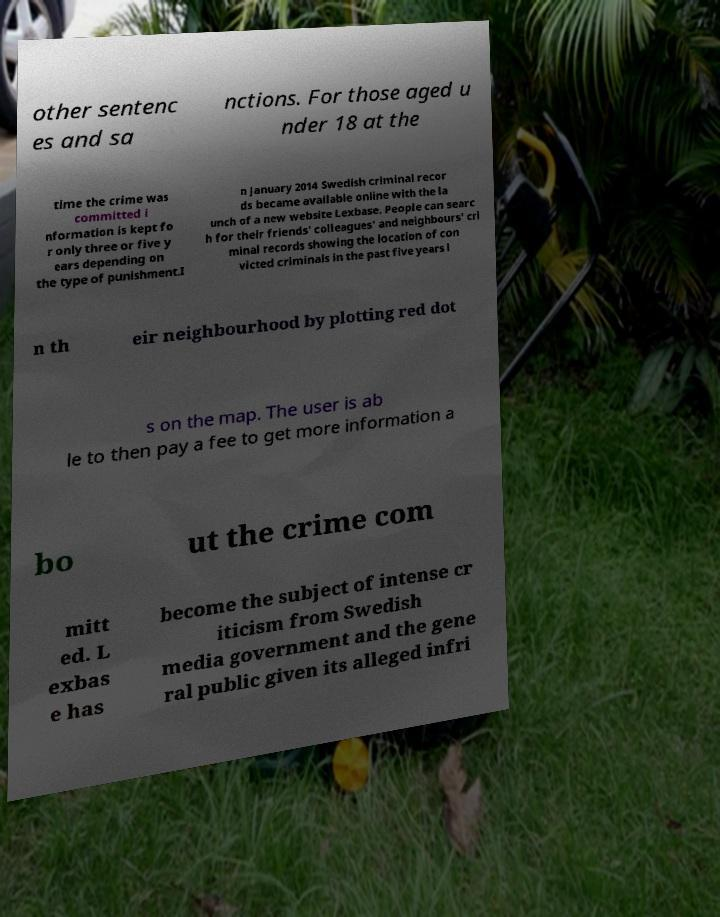For documentation purposes, I need the text within this image transcribed. Could you provide that? other sentenc es and sa nctions. For those aged u nder 18 at the time the crime was committed i nformation is kept fo r only three or five y ears depending on the type of punishment.I n January 2014 Swedish criminal recor ds became available online with the la unch of a new website Lexbase. People can searc h for their friends' colleagues' and neighbours' cri minal records showing the location of con victed criminals in the past five years i n th eir neighbourhood by plotting red dot s on the map. The user is ab le to then pay a fee to get more information a bo ut the crime com mitt ed. L exbas e has become the subject of intense cr iticism from Swedish media government and the gene ral public given its alleged infri 